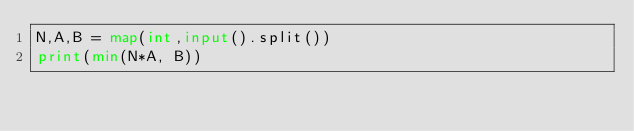Convert code to text. <code><loc_0><loc_0><loc_500><loc_500><_Python_>N,A,B = map(int,input().split())
print(min(N*A, B))</code> 